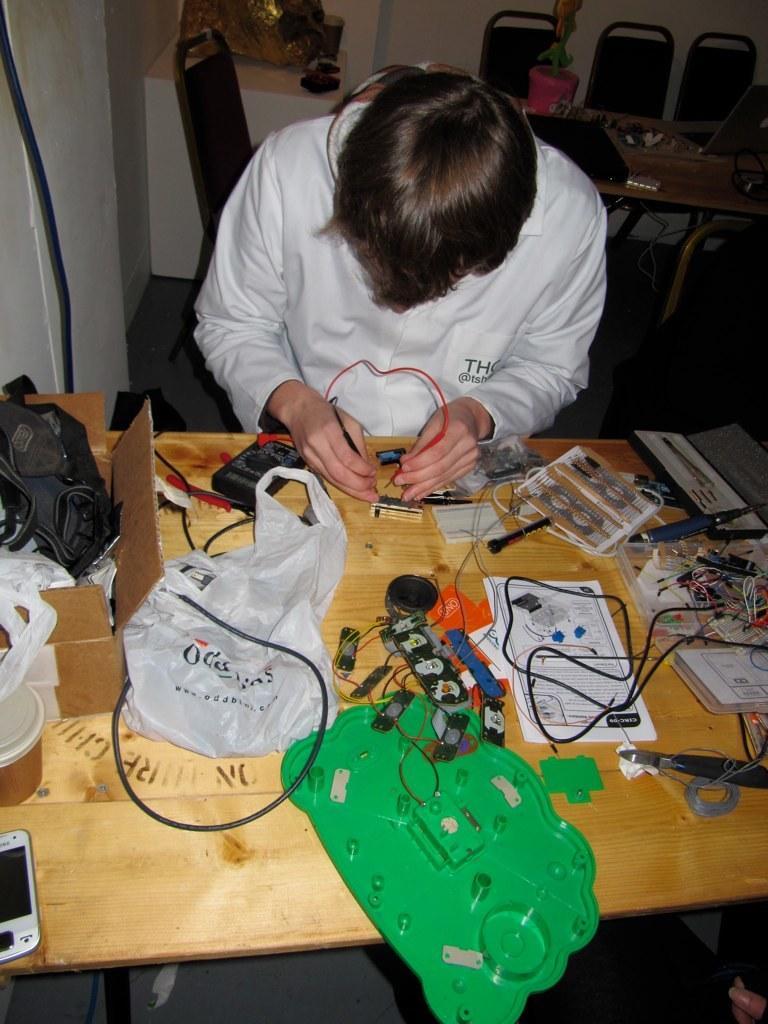Can you describe this image briefly? In this picture a person is working on some electrical stuff. The table is filled with electrical wires. Onto the left there is a mobile phone. 